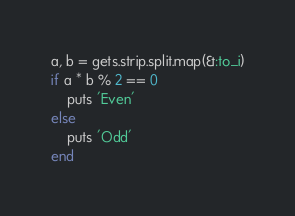<code> <loc_0><loc_0><loc_500><loc_500><_Ruby_>a, b = gets.strip.split.map(&:to_i)
if a * b % 2 == 0
    puts 'Even'
else
    puts 'Odd'
end
</code> 